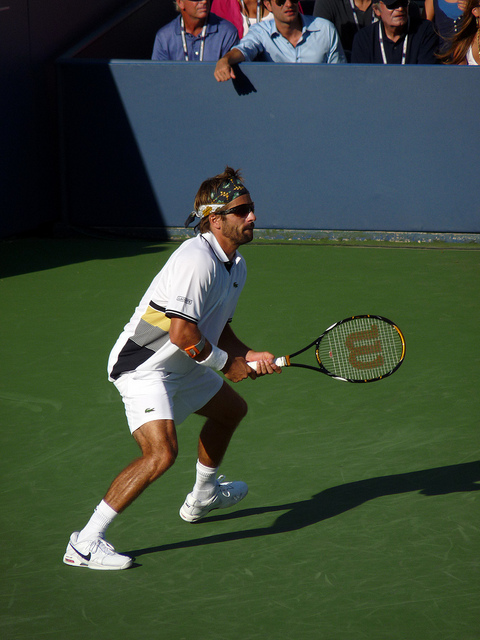<image>Who is winning this match? It is ambiguous who is winning the match. Who is winning this match? I don't know who is winning this match. It can be either the man or the man in white. 